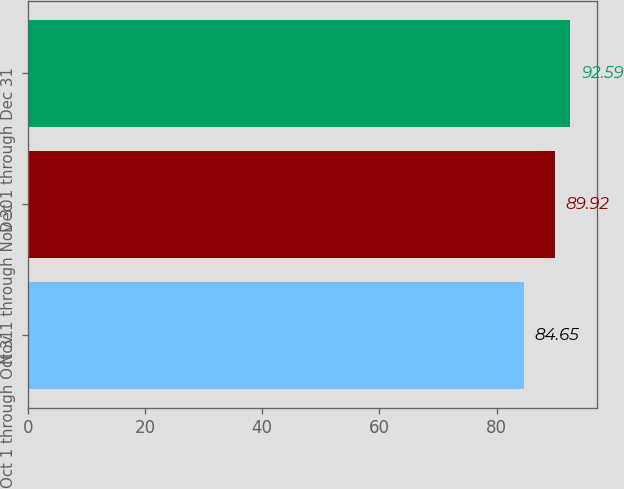Convert chart to OTSL. <chart><loc_0><loc_0><loc_500><loc_500><bar_chart><fcel>Oct 1 through Oct 31<fcel>Nov 1 through Nov 30<fcel>Dec 1 through Dec 31<nl><fcel>84.65<fcel>89.92<fcel>92.59<nl></chart> 